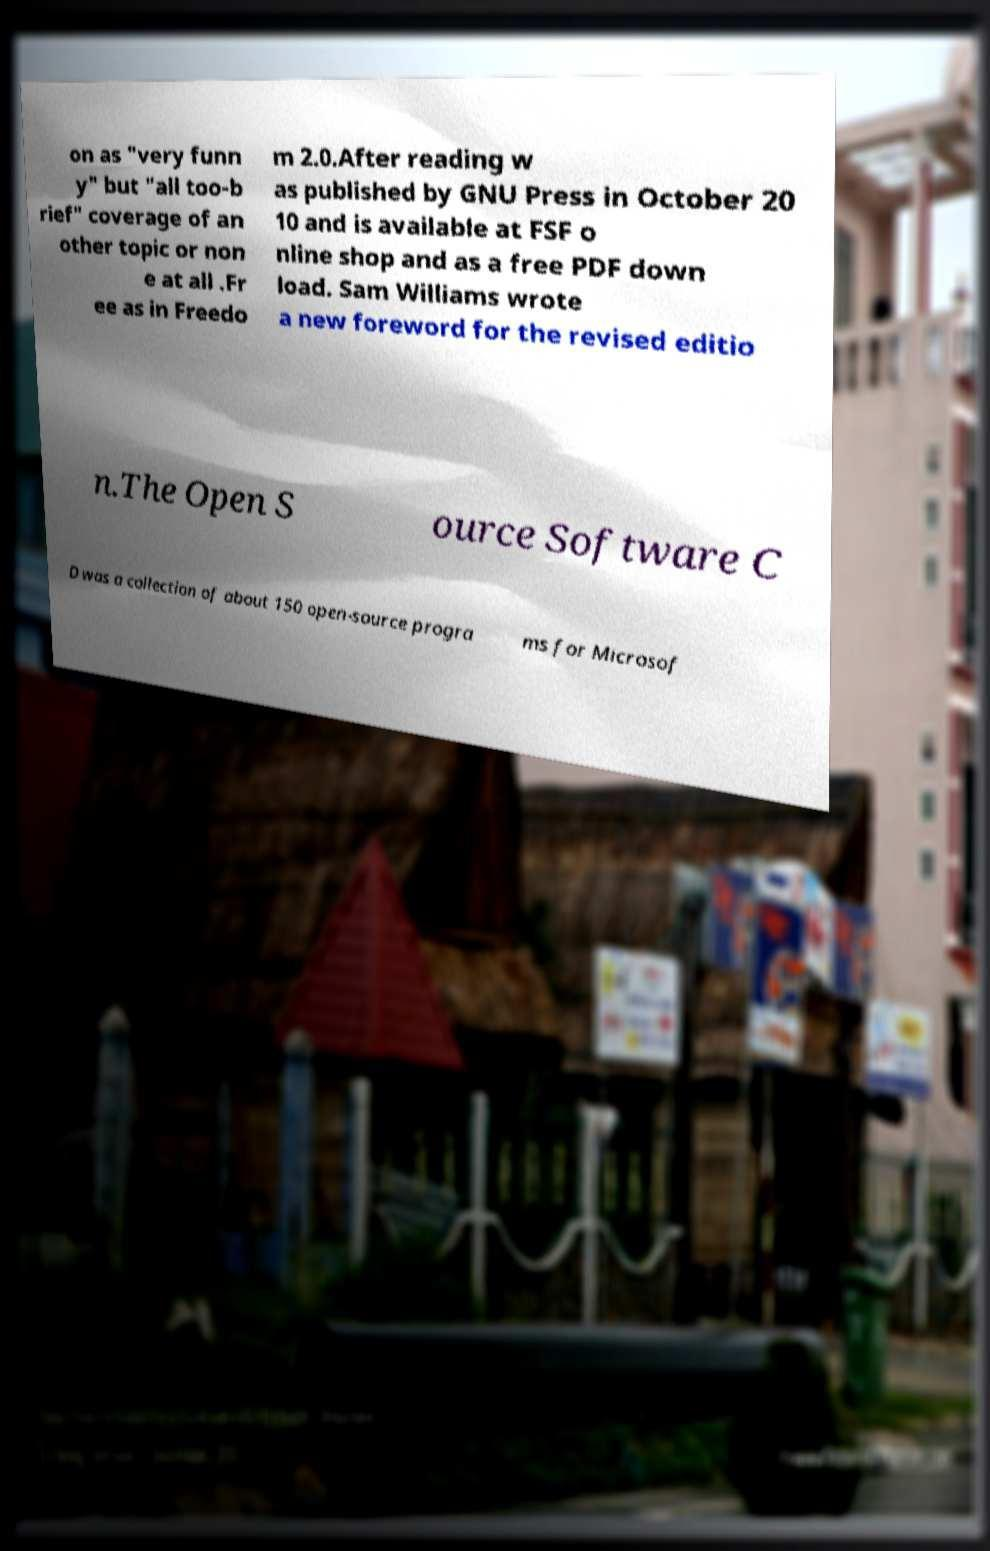What messages or text are displayed in this image? I need them in a readable, typed format. on as "very funn y" but "all too-b rief" coverage of an other topic or non e at all .Fr ee as in Freedo m 2.0.After reading w as published by GNU Press in October 20 10 and is available at FSF o nline shop and as a free PDF down load. Sam Williams wrote a new foreword for the revised editio n.The Open S ource Software C D was a collection of about 150 open-source progra ms for Microsof 